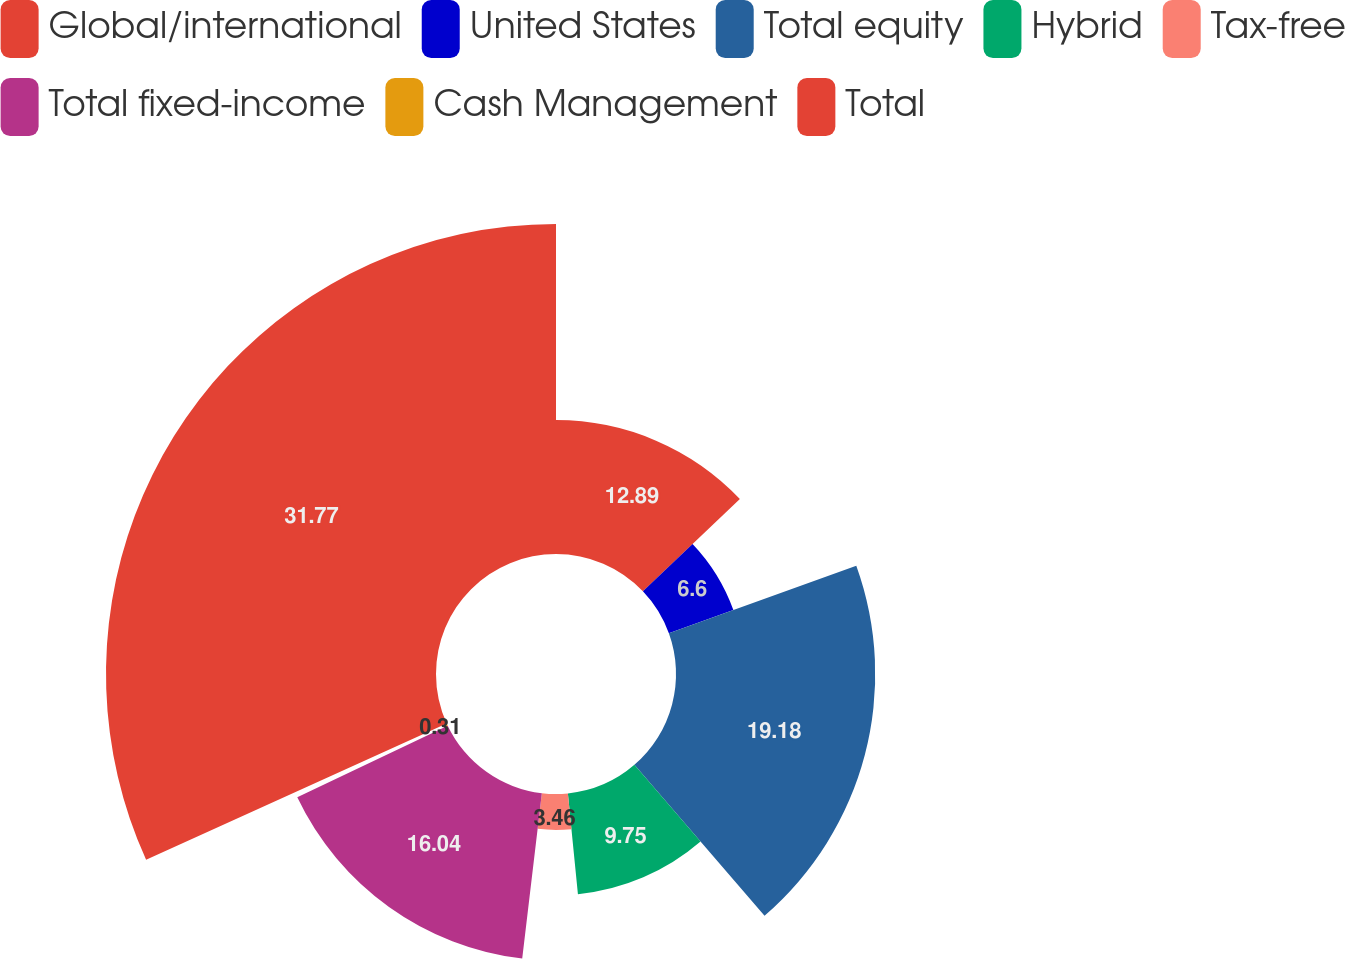Convert chart. <chart><loc_0><loc_0><loc_500><loc_500><pie_chart><fcel>Global/international<fcel>United States<fcel>Total equity<fcel>Hybrid<fcel>Tax-free<fcel>Total fixed-income<fcel>Cash Management<fcel>Total<nl><fcel>12.89%<fcel>6.6%<fcel>19.18%<fcel>9.75%<fcel>3.46%<fcel>16.04%<fcel>0.31%<fcel>31.77%<nl></chart> 